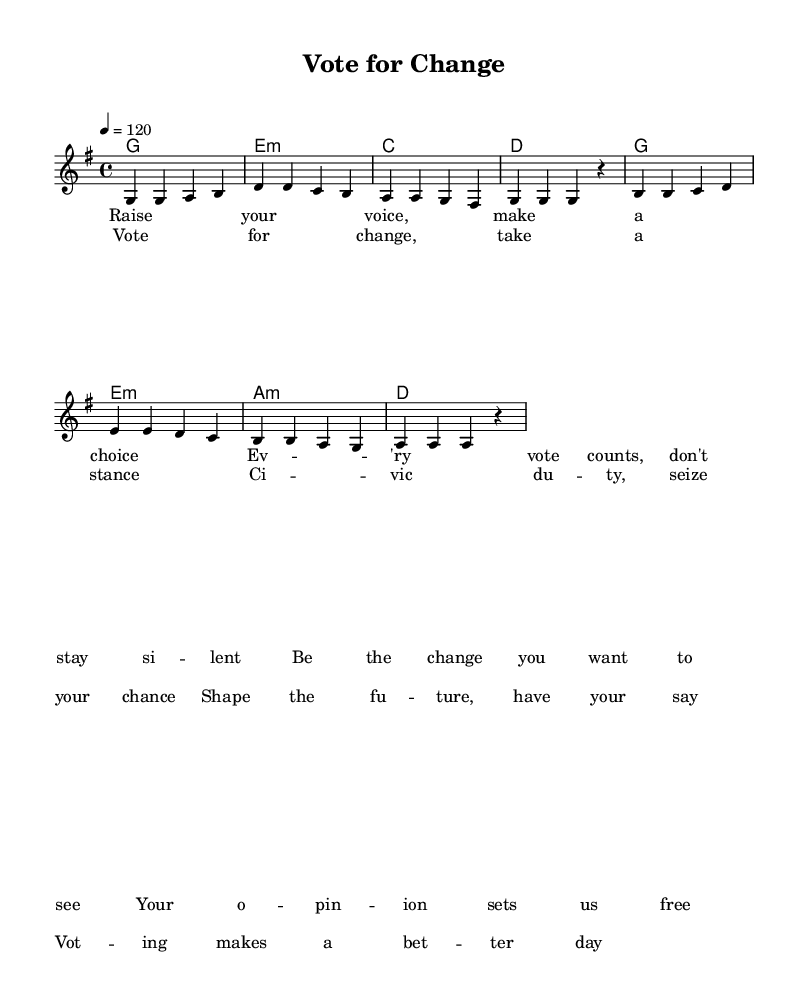What is the key signature of this music? The key signature is G major, which has one sharp (F sharp). This is indicated in the music notation before the staff.
Answer: G major What is the time signature of this music? The time signature is 4/4, which means there are 4 beats in a measure and the quarter note gets one beat. This can be found at the beginning of the score.
Answer: 4/4 What is the tempo marking in this music? The tempo marking is 120 beats per minute, indicated by the '4 = 120' notation in the score. This means a quarter note is played at a speed of 120 beats in one minute.
Answer: 120 How many measures are there in the melody section? The melody section consists of 8 measures, which can be counted by the vertical lines separating each measure in the score.
Answer: 8 What is the first lyric line of the chorus? The first lyric line of the chorus is "Vote for change, take a stance" as it is written under the corresponding notes in the lyrics section of the score.
Answer: Vote for change, take a stance Which musical mode is used in this piece? The piece utilizes a major mode, as indicated by the use of major chords and the overall tonal quality, primarily derived from the G major key signature.
Answer: Major 